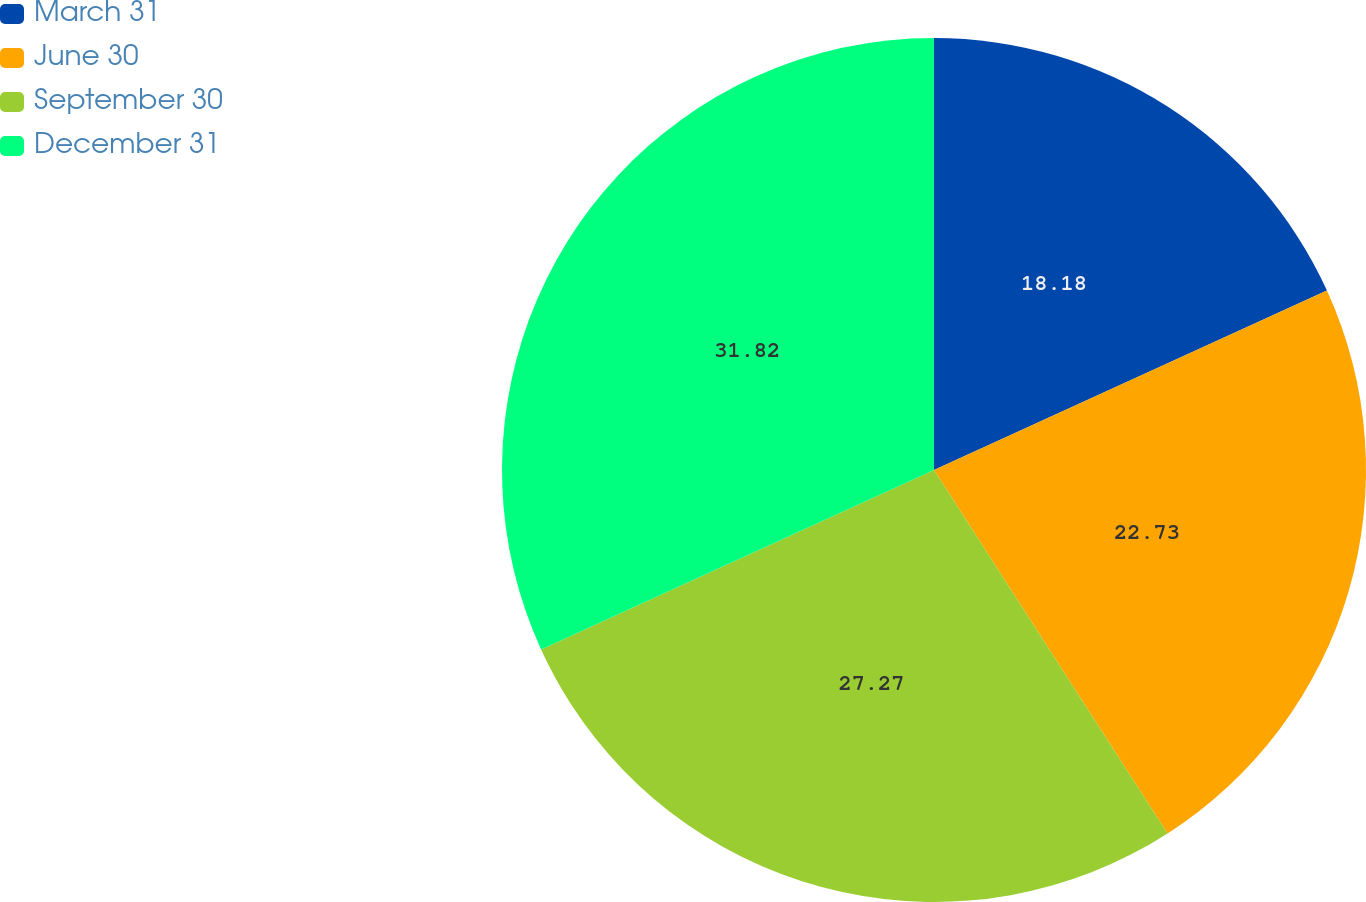<chart> <loc_0><loc_0><loc_500><loc_500><pie_chart><fcel>March 31<fcel>June 30<fcel>September 30<fcel>December 31<nl><fcel>18.18%<fcel>22.73%<fcel>27.27%<fcel>31.82%<nl></chart> 